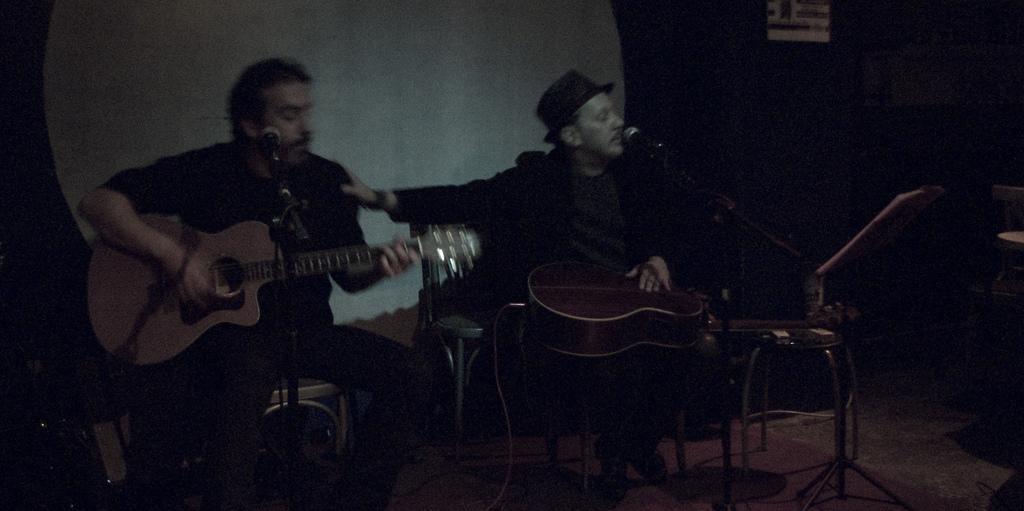How would you summarize this image in a sentence or two? In this image I can see two men are sitting and holding guitars. I can also see mice in front of them. 